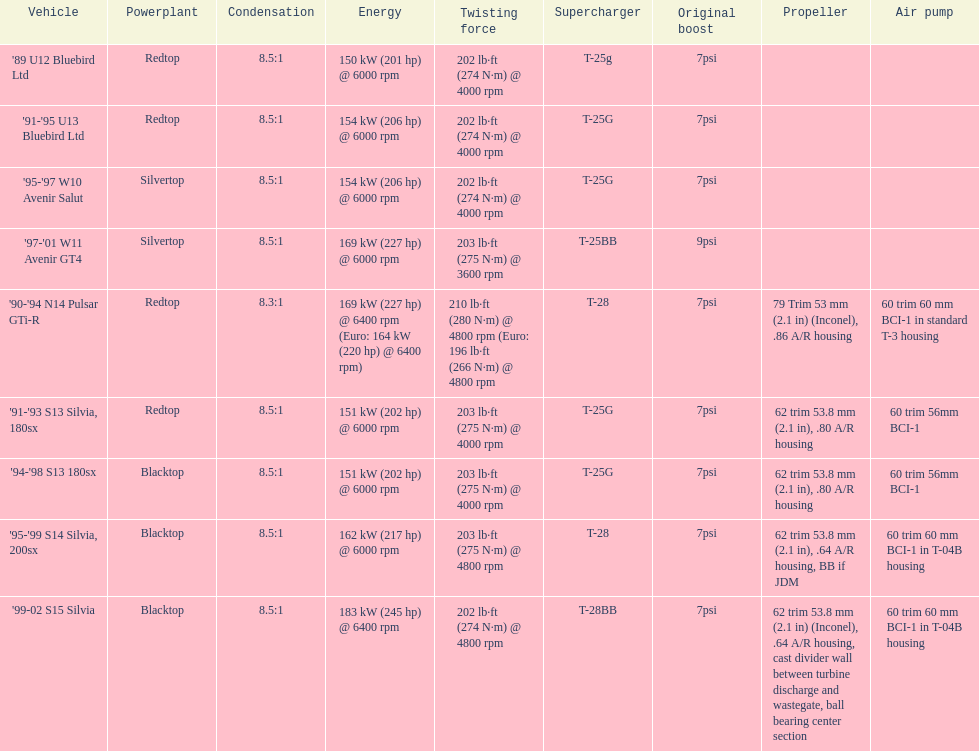Which vehicle's power is recorded beyond 6000 rpm? '90-'94 N14 Pulsar GTi-R, '99-02 S15 Silvia. 